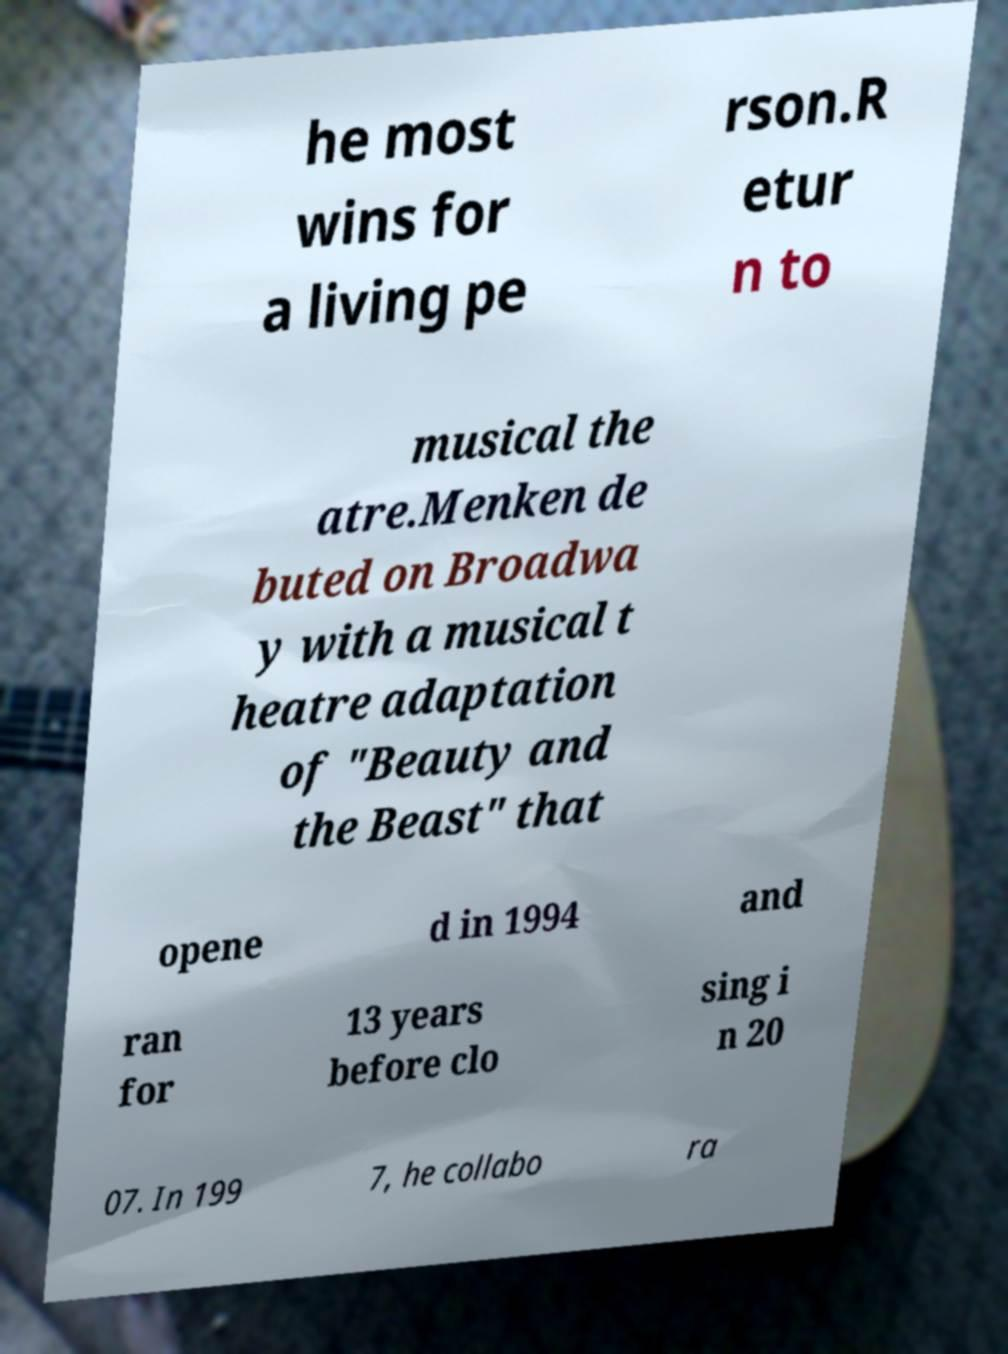Please identify and transcribe the text found in this image. he most wins for a living pe rson.R etur n to musical the atre.Menken de buted on Broadwa y with a musical t heatre adaptation of "Beauty and the Beast" that opene d in 1994 and ran for 13 years before clo sing i n 20 07. In 199 7, he collabo ra 